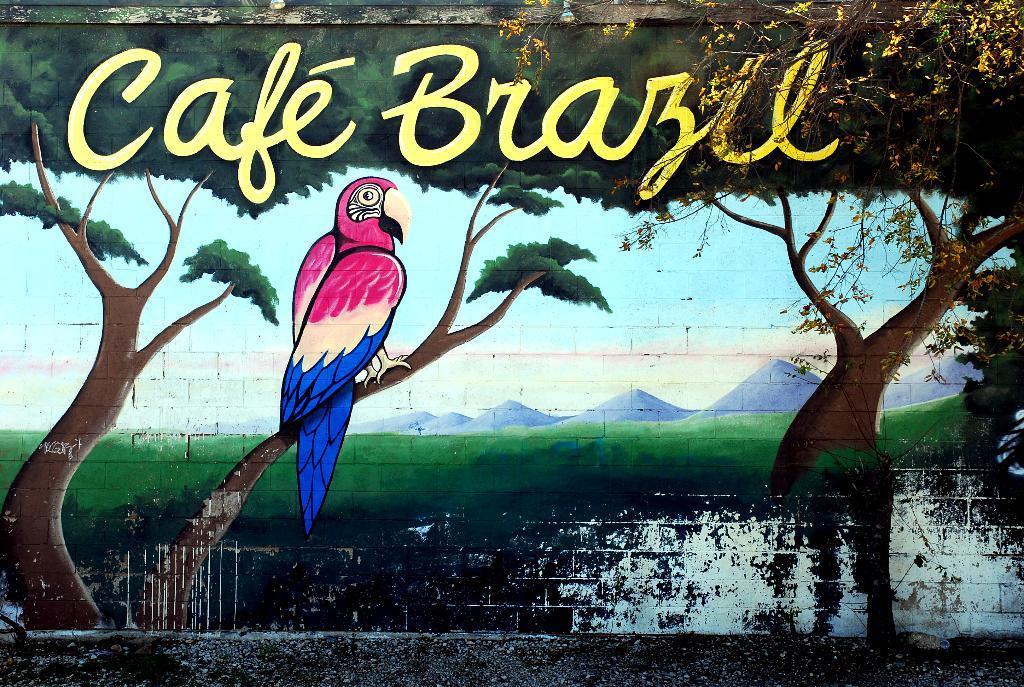Can you describe this image briefly? In this image, we can see a wall contains depiction of a parrot and trees. There is a branch in the top right of the image. There is a text at the top of the image. 